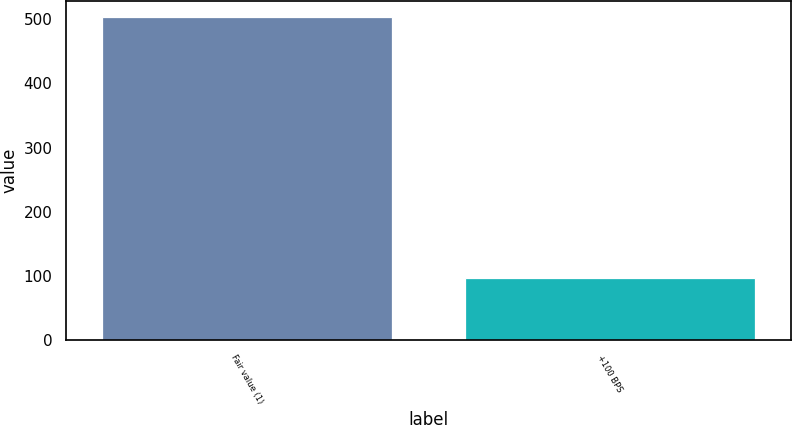Convert chart to OTSL. <chart><loc_0><loc_0><loc_500><loc_500><bar_chart><fcel>Fair value (1)<fcel>+100 BPS<nl><fcel>503<fcel>97<nl></chart> 